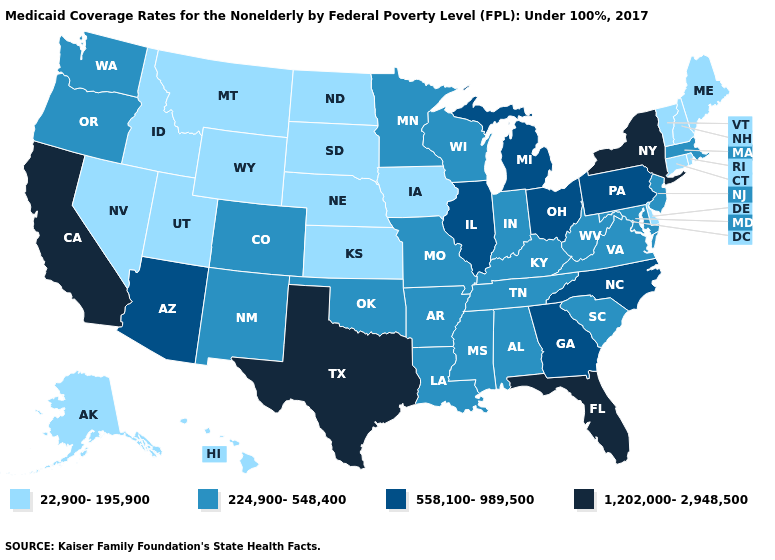Does Delaware have the lowest value in the South?
Quick response, please. Yes. What is the value of Hawaii?
Short answer required. 22,900-195,900. What is the highest value in the USA?
Short answer required. 1,202,000-2,948,500. Name the states that have a value in the range 558,100-989,500?
Answer briefly. Arizona, Georgia, Illinois, Michigan, North Carolina, Ohio, Pennsylvania. Name the states that have a value in the range 558,100-989,500?
Concise answer only. Arizona, Georgia, Illinois, Michigan, North Carolina, Ohio, Pennsylvania. Name the states that have a value in the range 22,900-195,900?
Give a very brief answer. Alaska, Connecticut, Delaware, Hawaii, Idaho, Iowa, Kansas, Maine, Montana, Nebraska, Nevada, New Hampshire, North Dakota, Rhode Island, South Dakota, Utah, Vermont, Wyoming. Which states hav the highest value in the South?
Keep it brief. Florida, Texas. Among the states that border Arkansas , which have the lowest value?
Answer briefly. Louisiana, Mississippi, Missouri, Oklahoma, Tennessee. Does Montana have the highest value in the USA?
Give a very brief answer. No. Name the states that have a value in the range 22,900-195,900?
Keep it brief. Alaska, Connecticut, Delaware, Hawaii, Idaho, Iowa, Kansas, Maine, Montana, Nebraska, Nevada, New Hampshire, North Dakota, Rhode Island, South Dakota, Utah, Vermont, Wyoming. Does the map have missing data?
Keep it brief. No. What is the value of Alaska?
Answer briefly. 22,900-195,900. Which states hav the highest value in the MidWest?
Give a very brief answer. Illinois, Michigan, Ohio. Among the states that border Virginia , does North Carolina have the highest value?
Concise answer only. Yes. Does Montana have a lower value than New Mexico?
Concise answer only. Yes. 